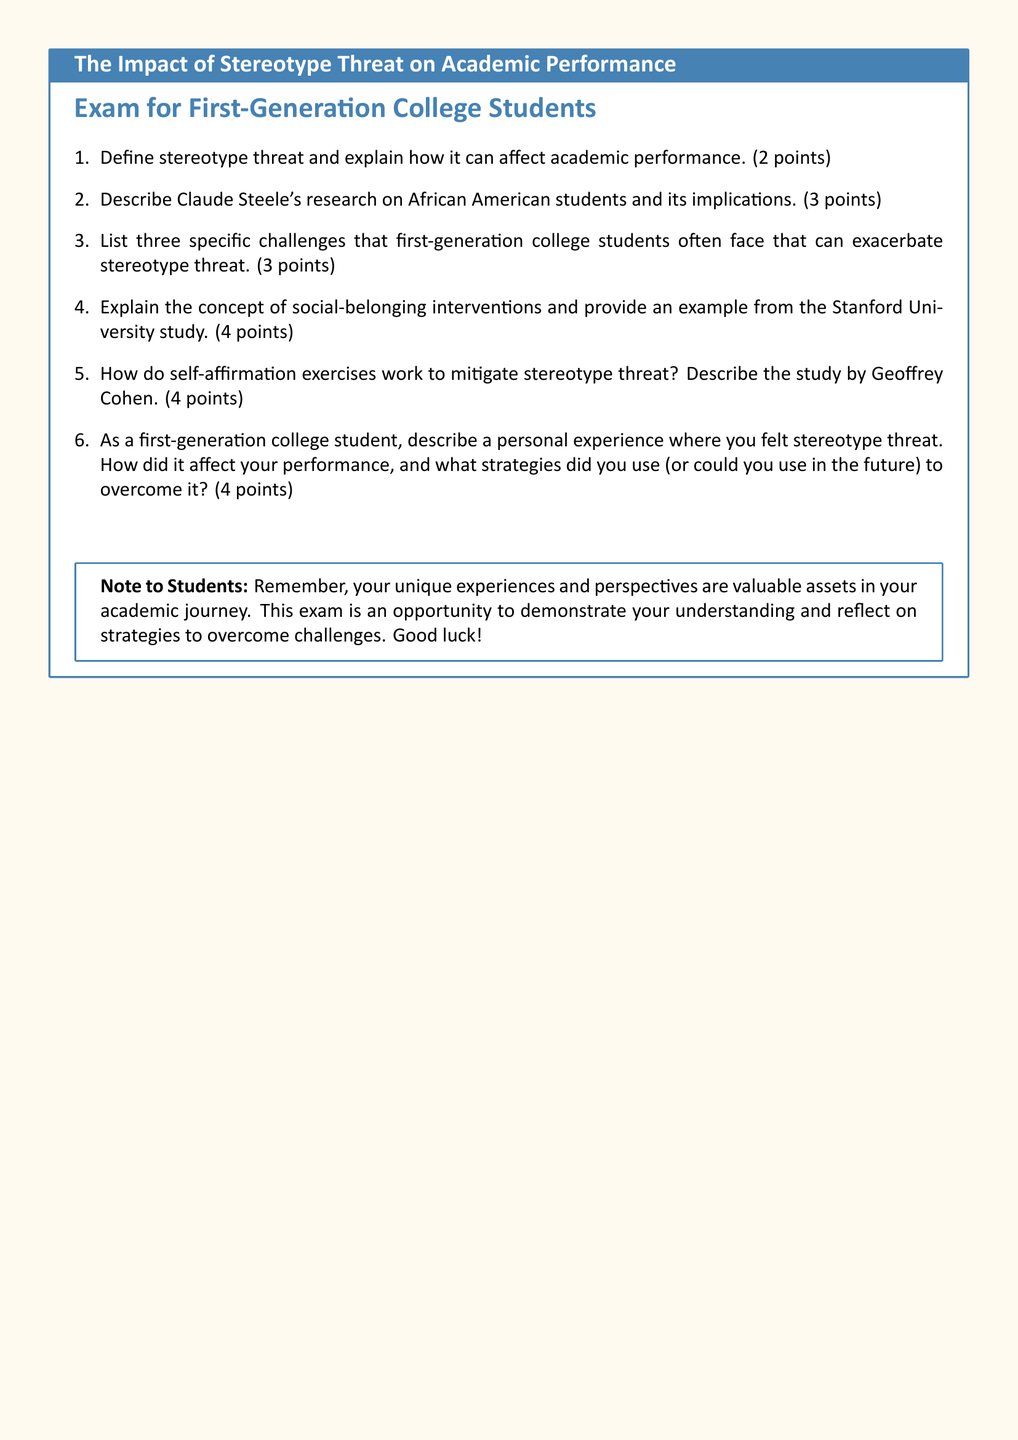what is the title of the document? The title of the document is specified in the tcolorbox at the beginning.
Answer: The Impact of Stereotype Threat on Academic Performance how many points is question 2 worth? The value of each question is indicated in the document.
Answer: 3 points who conducted the study on self-affirmation exercises? The document specifies Geoffrey Cohen as the person who conducted the relevant study.
Answer: Geoffrey Cohen what is a social-belonging intervention? The concept of social-belonging interventions is described in the document, providing an example of their function.
Answer: Programs to enhance students' sense of belonging how many challenges must be listed in response to question 3? The number of challenges to be listed is stated explicitly in the question.
Answer: Three what type of students does this exam focus on? The introductory note clarifies which group of students this exam is aimed at.
Answer: First-Generation College Students what is the total number of questions in the exam? The count of questions can be found in the enumerated list at the beginning of the document.
Answer: Six what personal experience is requested in question 6? Question 6 asks for a personal experience related to stereotype threat.
Answer: Experience with stereotype threat what should students remember according to the note? The note to students encourages a specific mindset that they should keep in mind.
Answer: Unique experiences and perspectives 